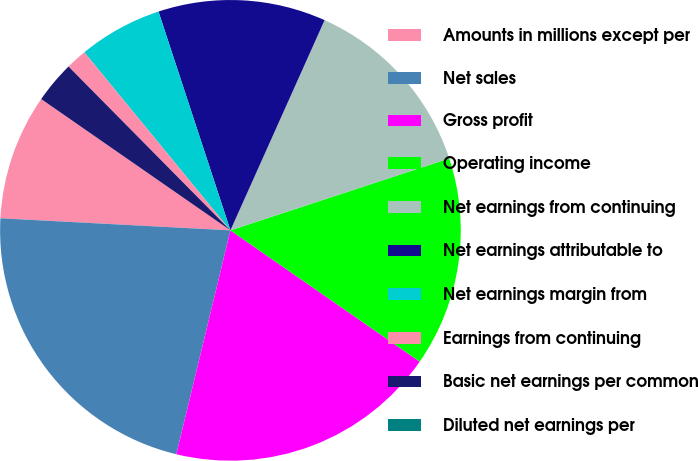Convert chart to OTSL. <chart><loc_0><loc_0><loc_500><loc_500><pie_chart><fcel>Amounts in millions except per<fcel>Net sales<fcel>Gross profit<fcel>Operating income<fcel>Net earnings from continuing<fcel>Net earnings attributable to<fcel>Net earnings margin from<fcel>Earnings from continuing<fcel>Basic net earnings per common<fcel>Diluted net earnings per<nl><fcel>8.82%<fcel>22.06%<fcel>19.12%<fcel>14.71%<fcel>13.24%<fcel>11.76%<fcel>5.88%<fcel>1.47%<fcel>2.94%<fcel>0.0%<nl></chart> 